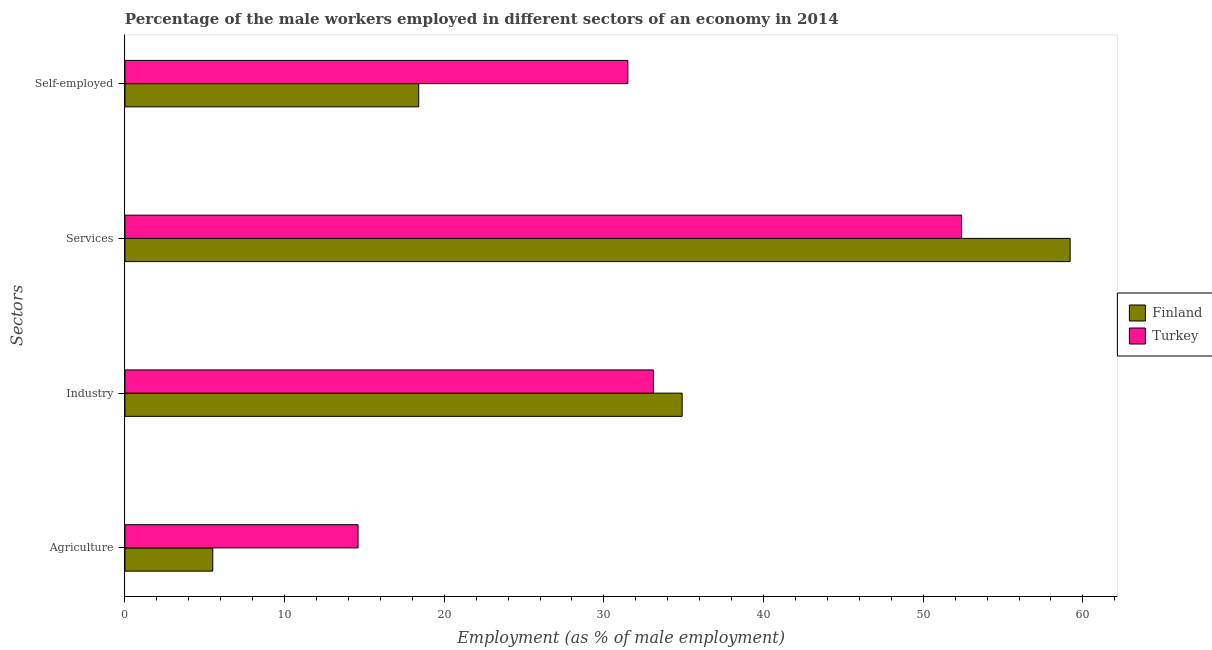How many different coloured bars are there?
Give a very brief answer. 2. Are the number of bars per tick equal to the number of legend labels?
Your answer should be compact. Yes. Are the number of bars on each tick of the Y-axis equal?
Your answer should be compact. Yes. How many bars are there on the 1st tick from the top?
Your response must be concise. 2. How many bars are there on the 2nd tick from the bottom?
Keep it short and to the point. 2. What is the label of the 3rd group of bars from the top?
Your answer should be compact. Industry. What is the percentage of male workers in services in Turkey?
Keep it short and to the point. 52.4. Across all countries, what is the maximum percentage of male workers in agriculture?
Provide a succinct answer. 14.6. Across all countries, what is the minimum percentage of self employed male workers?
Offer a very short reply. 18.4. In which country was the percentage of male workers in services maximum?
Your answer should be very brief. Finland. In which country was the percentage of male workers in agriculture minimum?
Keep it short and to the point. Finland. What is the total percentage of male workers in agriculture in the graph?
Ensure brevity in your answer.  20.1. What is the difference between the percentage of male workers in industry in Turkey and that in Finland?
Make the answer very short. -1.8. What is the difference between the percentage of male workers in industry in Turkey and the percentage of self employed male workers in Finland?
Make the answer very short. 14.7. What is the average percentage of male workers in industry per country?
Your answer should be compact. 34. What is the difference between the percentage of male workers in services and percentage of male workers in industry in Finland?
Give a very brief answer. 24.3. What is the ratio of the percentage of male workers in agriculture in Finland to that in Turkey?
Give a very brief answer. 0.38. Is the percentage of male workers in agriculture in Finland less than that in Turkey?
Provide a succinct answer. Yes. What is the difference between the highest and the second highest percentage of male workers in services?
Offer a terse response. 6.8. What is the difference between the highest and the lowest percentage of male workers in services?
Make the answer very short. 6.8. Is the sum of the percentage of male workers in services in Finland and Turkey greater than the maximum percentage of self employed male workers across all countries?
Your answer should be compact. Yes. What does the 2nd bar from the bottom in Self-employed represents?
Give a very brief answer. Turkey. Is it the case that in every country, the sum of the percentage of male workers in agriculture and percentage of male workers in industry is greater than the percentage of male workers in services?
Keep it short and to the point. No. How many bars are there?
Your response must be concise. 8. Are all the bars in the graph horizontal?
Your answer should be very brief. Yes. Are the values on the major ticks of X-axis written in scientific E-notation?
Provide a succinct answer. No. Does the graph contain any zero values?
Offer a terse response. No. Does the graph contain grids?
Provide a succinct answer. No. How many legend labels are there?
Provide a short and direct response. 2. What is the title of the graph?
Your answer should be very brief. Percentage of the male workers employed in different sectors of an economy in 2014. Does "Somalia" appear as one of the legend labels in the graph?
Provide a succinct answer. No. What is the label or title of the X-axis?
Provide a succinct answer. Employment (as % of male employment). What is the label or title of the Y-axis?
Offer a very short reply. Sectors. What is the Employment (as % of male employment) in Turkey in Agriculture?
Your response must be concise. 14.6. What is the Employment (as % of male employment) of Finland in Industry?
Offer a terse response. 34.9. What is the Employment (as % of male employment) in Turkey in Industry?
Your response must be concise. 33.1. What is the Employment (as % of male employment) in Finland in Services?
Ensure brevity in your answer.  59.2. What is the Employment (as % of male employment) of Turkey in Services?
Offer a very short reply. 52.4. What is the Employment (as % of male employment) of Finland in Self-employed?
Give a very brief answer. 18.4. What is the Employment (as % of male employment) of Turkey in Self-employed?
Ensure brevity in your answer.  31.5. Across all Sectors, what is the maximum Employment (as % of male employment) of Finland?
Your answer should be compact. 59.2. Across all Sectors, what is the maximum Employment (as % of male employment) in Turkey?
Provide a succinct answer. 52.4. Across all Sectors, what is the minimum Employment (as % of male employment) in Turkey?
Offer a terse response. 14.6. What is the total Employment (as % of male employment) in Finland in the graph?
Provide a succinct answer. 118. What is the total Employment (as % of male employment) of Turkey in the graph?
Keep it short and to the point. 131.6. What is the difference between the Employment (as % of male employment) of Finland in Agriculture and that in Industry?
Offer a very short reply. -29.4. What is the difference between the Employment (as % of male employment) in Turkey in Agriculture and that in Industry?
Give a very brief answer. -18.5. What is the difference between the Employment (as % of male employment) in Finland in Agriculture and that in Services?
Provide a succinct answer. -53.7. What is the difference between the Employment (as % of male employment) of Turkey in Agriculture and that in Services?
Keep it short and to the point. -37.8. What is the difference between the Employment (as % of male employment) in Finland in Agriculture and that in Self-employed?
Your answer should be very brief. -12.9. What is the difference between the Employment (as % of male employment) of Turkey in Agriculture and that in Self-employed?
Your response must be concise. -16.9. What is the difference between the Employment (as % of male employment) of Finland in Industry and that in Services?
Provide a succinct answer. -24.3. What is the difference between the Employment (as % of male employment) of Turkey in Industry and that in Services?
Your answer should be very brief. -19.3. What is the difference between the Employment (as % of male employment) in Finland in Services and that in Self-employed?
Offer a terse response. 40.8. What is the difference between the Employment (as % of male employment) in Turkey in Services and that in Self-employed?
Offer a terse response. 20.9. What is the difference between the Employment (as % of male employment) in Finland in Agriculture and the Employment (as % of male employment) in Turkey in Industry?
Ensure brevity in your answer.  -27.6. What is the difference between the Employment (as % of male employment) of Finland in Agriculture and the Employment (as % of male employment) of Turkey in Services?
Your response must be concise. -46.9. What is the difference between the Employment (as % of male employment) in Finland in Industry and the Employment (as % of male employment) in Turkey in Services?
Ensure brevity in your answer.  -17.5. What is the difference between the Employment (as % of male employment) in Finland in Industry and the Employment (as % of male employment) in Turkey in Self-employed?
Offer a very short reply. 3.4. What is the difference between the Employment (as % of male employment) of Finland in Services and the Employment (as % of male employment) of Turkey in Self-employed?
Provide a short and direct response. 27.7. What is the average Employment (as % of male employment) in Finland per Sectors?
Ensure brevity in your answer.  29.5. What is the average Employment (as % of male employment) in Turkey per Sectors?
Your response must be concise. 32.9. What is the difference between the Employment (as % of male employment) in Finland and Employment (as % of male employment) in Turkey in Services?
Your answer should be very brief. 6.8. What is the ratio of the Employment (as % of male employment) of Finland in Agriculture to that in Industry?
Provide a succinct answer. 0.16. What is the ratio of the Employment (as % of male employment) in Turkey in Agriculture to that in Industry?
Offer a terse response. 0.44. What is the ratio of the Employment (as % of male employment) in Finland in Agriculture to that in Services?
Your response must be concise. 0.09. What is the ratio of the Employment (as % of male employment) of Turkey in Agriculture to that in Services?
Ensure brevity in your answer.  0.28. What is the ratio of the Employment (as % of male employment) of Finland in Agriculture to that in Self-employed?
Offer a terse response. 0.3. What is the ratio of the Employment (as % of male employment) of Turkey in Agriculture to that in Self-employed?
Your answer should be compact. 0.46. What is the ratio of the Employment (as % of male employment) of Finland in Industry to that in Services?
Your response must be concise. 0.59. What is the ratio of the Employment (as % of male employment) in Turkey in Industry to that in Services?
Give a very brief answer. 0.63. What is the ratio of the Employment (as % of male employment) of Finland in Industry to that in Self-employed?
Your response must be concise. 1.9. What is the ratio of the Employment (as % of male employment) of Turkey in Industry to that in Self-employed?
Give a very brief answer. 1.05. What is the ratio of the Employment (as % of male employment) of Finland in Services to that in Self-employed?
Your answer should be very brief. 3.22. What is the ratio of the Employment (as % of male employment) in Turkey in Services to that in Self-employed?
Provide a short and direct response. 1.66. What is the difference between the highest and the second highest Employment (as % of male employment) in Finland?
Make the answer very short. 24.3. What is the difference between the highest and the second highest Employment (as % of male employment) in Turkey?
Provide a short and direct response. 19.3. What is the difference between the highest and the lowest Employment (as % of male employment) of Finland?
Make the answer very short. 53.7. What is the difference between the highest and the lowest Employment (as % of male employment) in Turkey?
Make the answer very short. 37.8. 